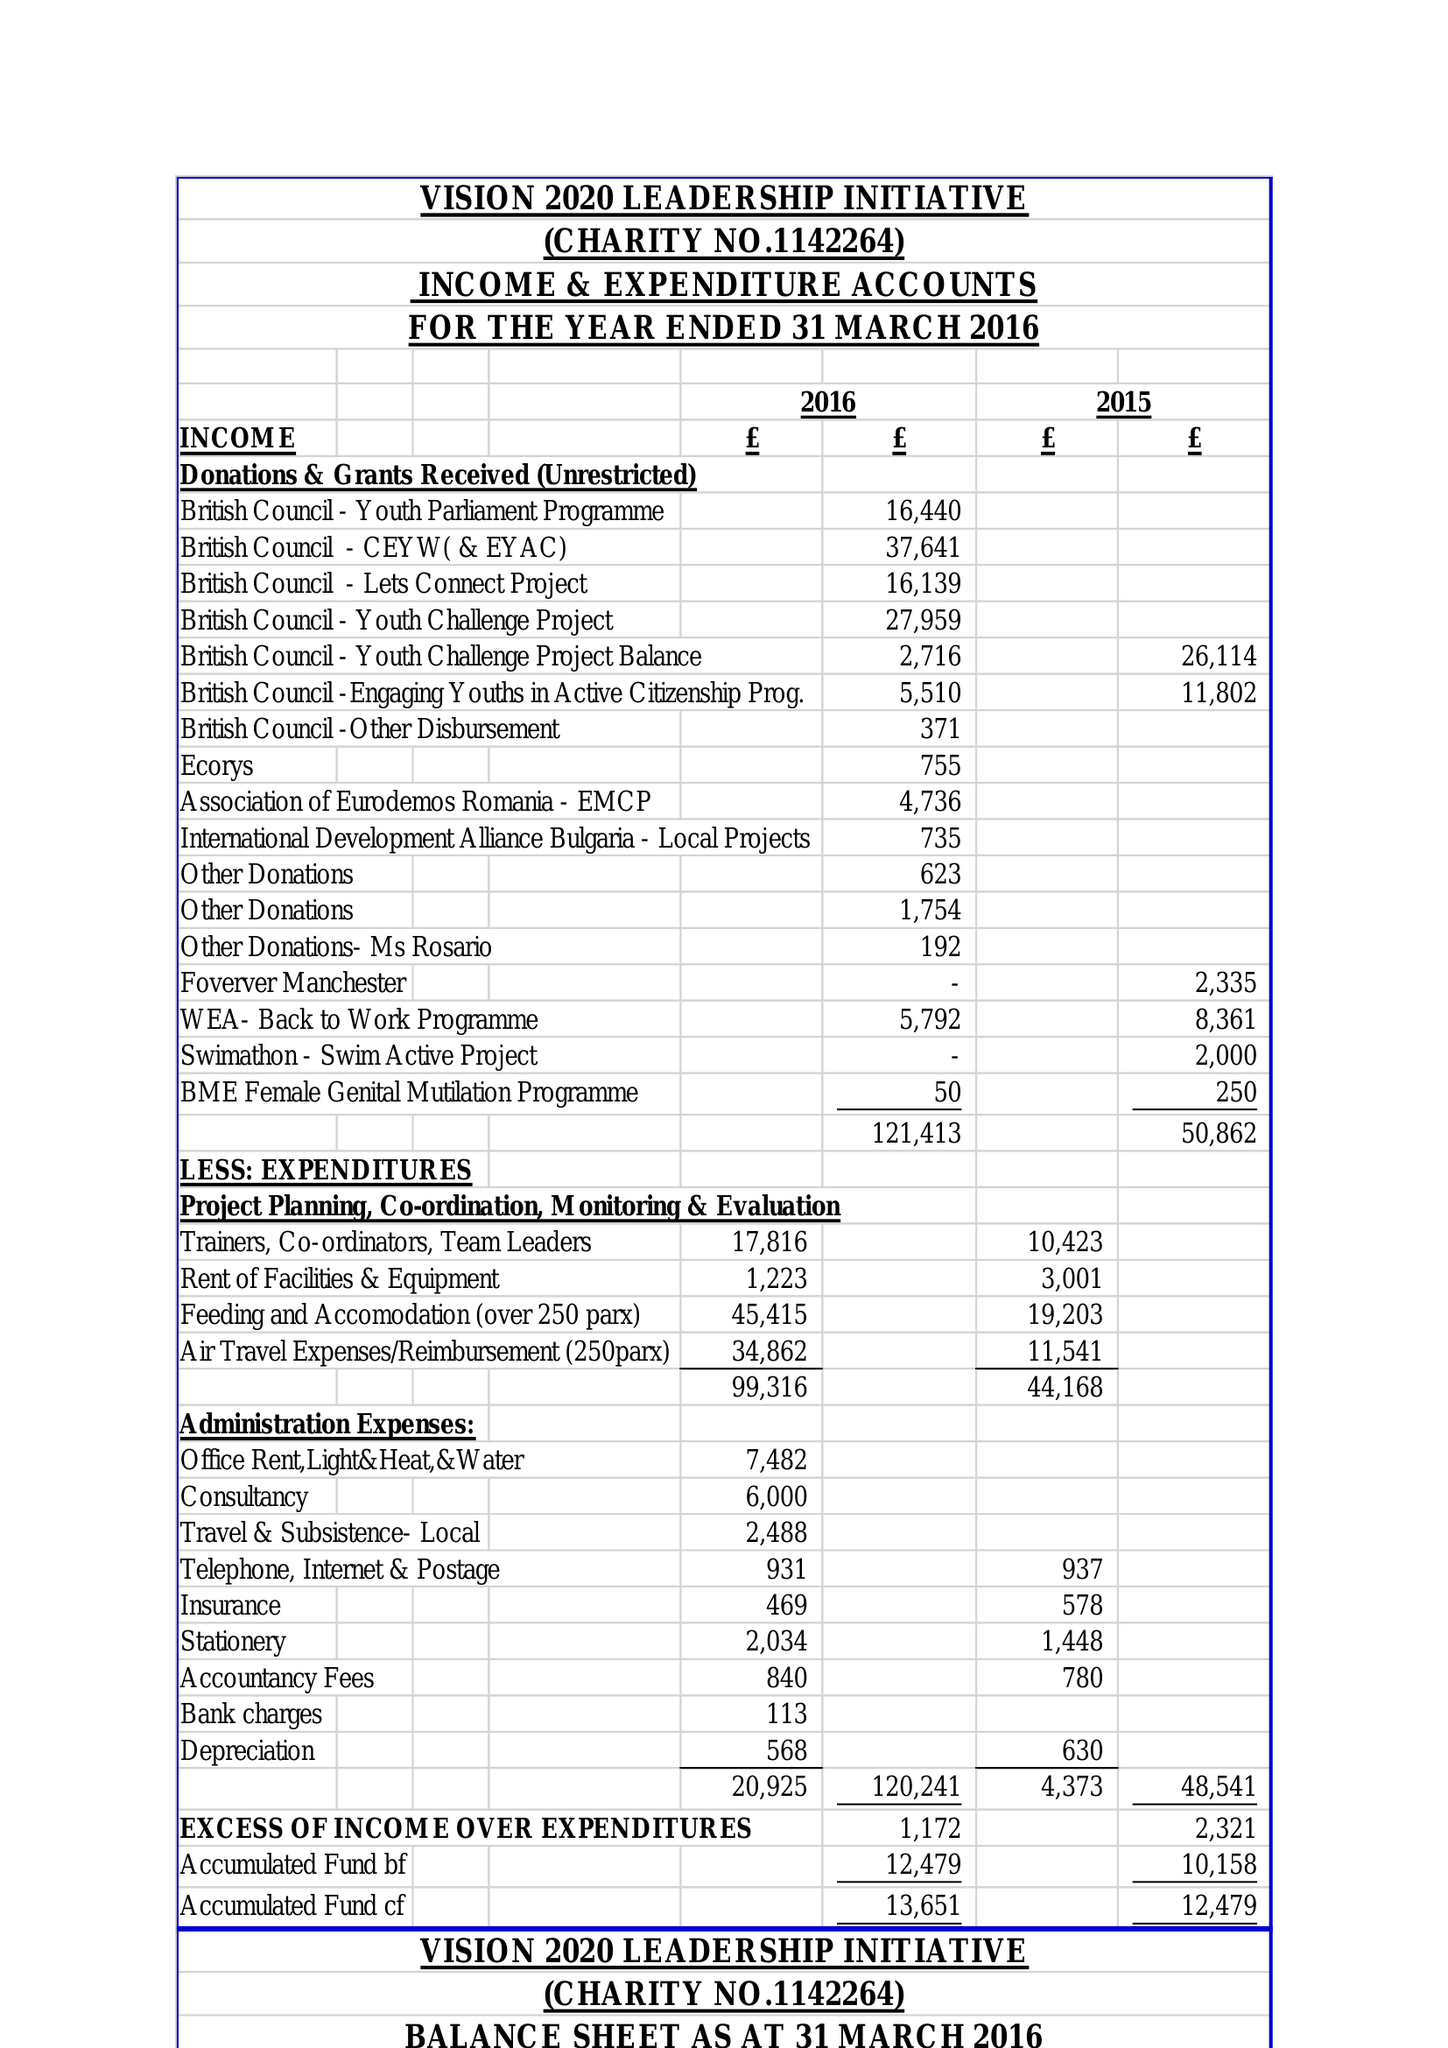What is the value for the address__post_town?
Answer the question using a single word or phrase. MANCHESTER 